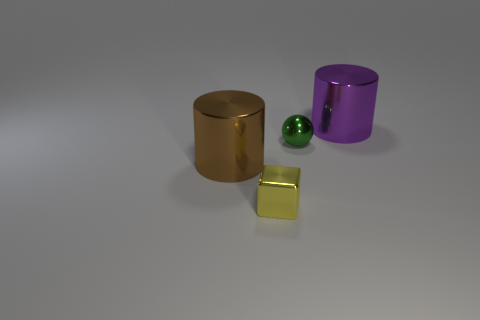How many tiny brown things are there?
Your response must be concise. 0. There is a yellow shiny block that is in front of the big brown shiny thing; what size is it?
Offer a very short reply. Small. Do the sphere and the purple cylinder have the same size?
Provide a succinct answer. No. How many objects are either blocks or small shiny things that are behind the tiny yellow metallic block?
Your response must be concise. 2. Is there any other thing that has the same color as the tiny ball?
Give a very brief answer. No. Is the big purple metal thing the same shape as the large brown object?
Make the answer very short. Yes. There is a thing in front of the large metallic object that is in front of the shiny cylinder that is to the right of the small yellow object; how big is it?
Provide a short and direct response. Small. What number of other objects are the same material as the green thing?
Give a very brief answer. 3. The big object in front of the purple shiny object is what color?
Provide a short and direct response. Brown. Is there another big metal thing that has the same shape as the purple object?
Your answer should be very brief. Yes. 